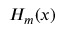<formula> <loc_0><loc_0><loc_500><loc_500>H _ { m } ( x )</formula> 